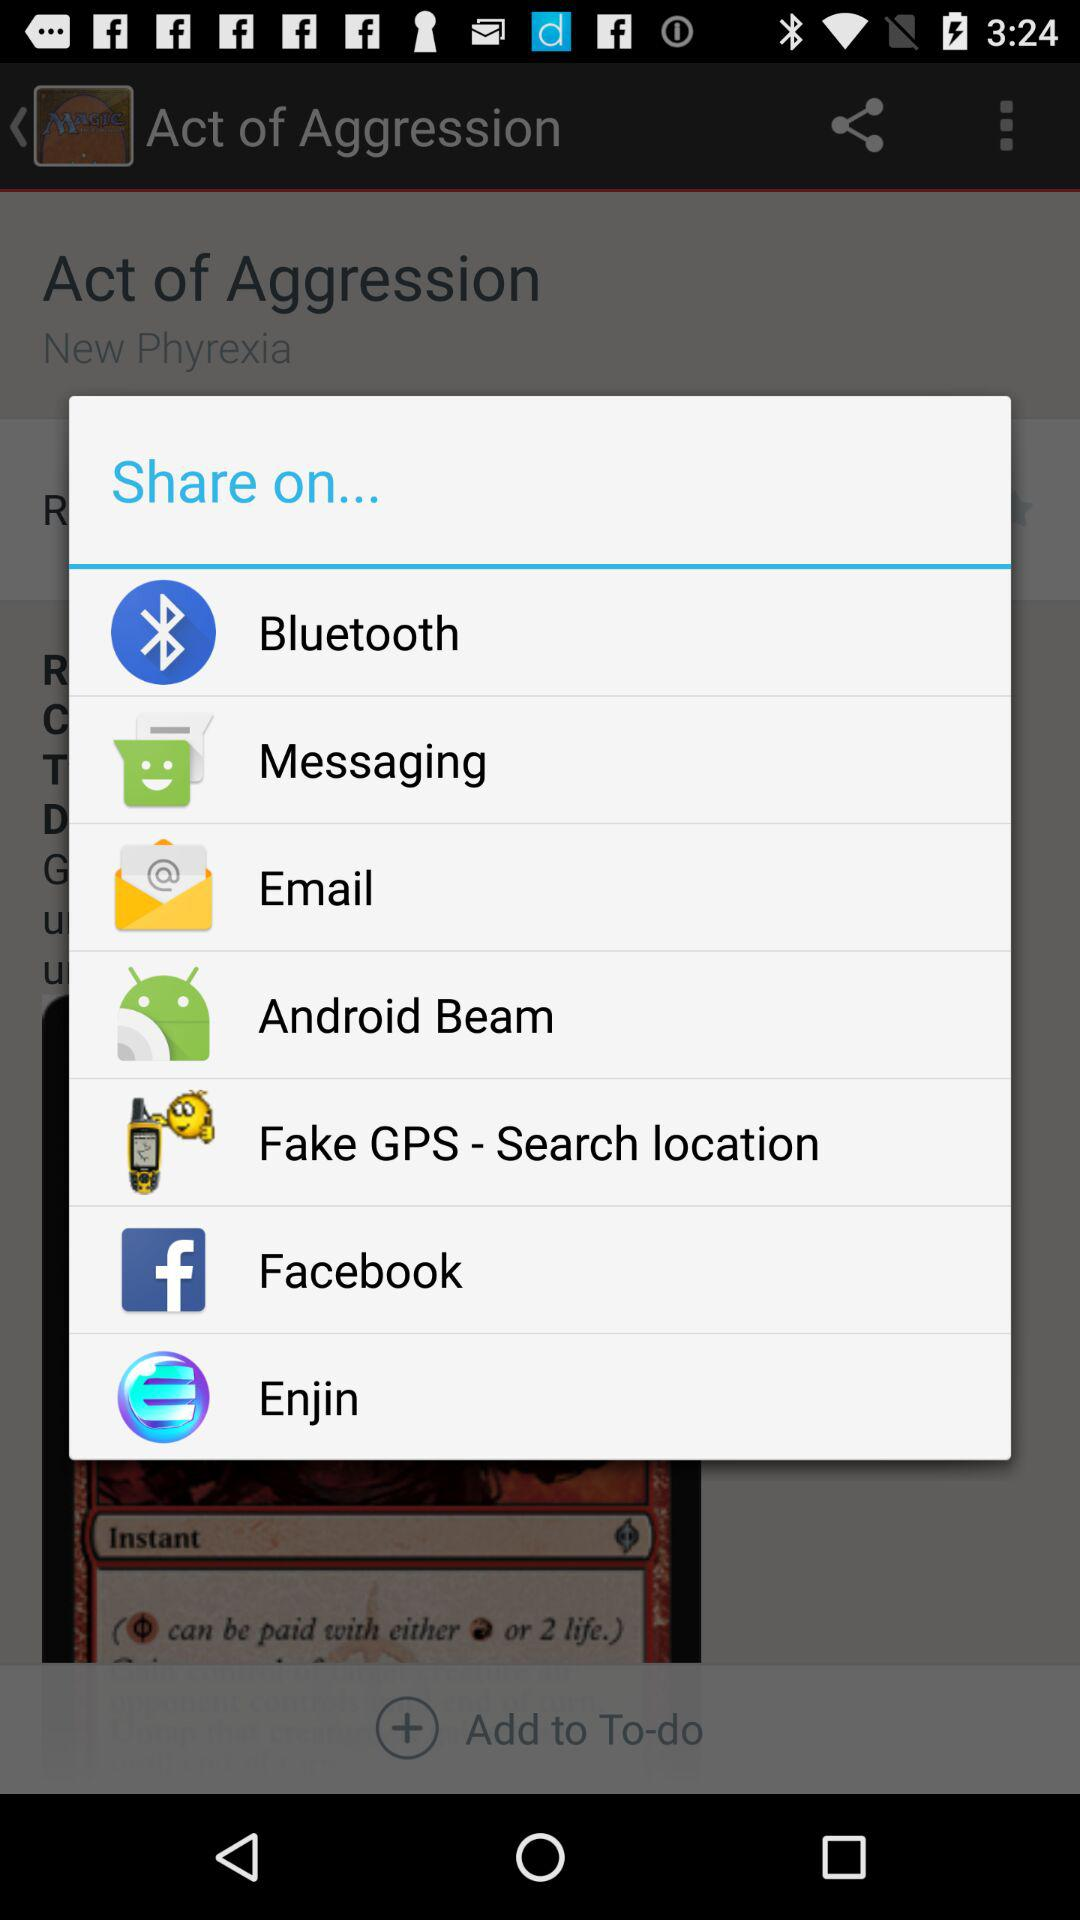Through which applications can we share? You can share through "Bluetooth", "Messaging", "Email", "Android Beam", "Fake GPS - Search location", "Facebook" and "Enjin". 